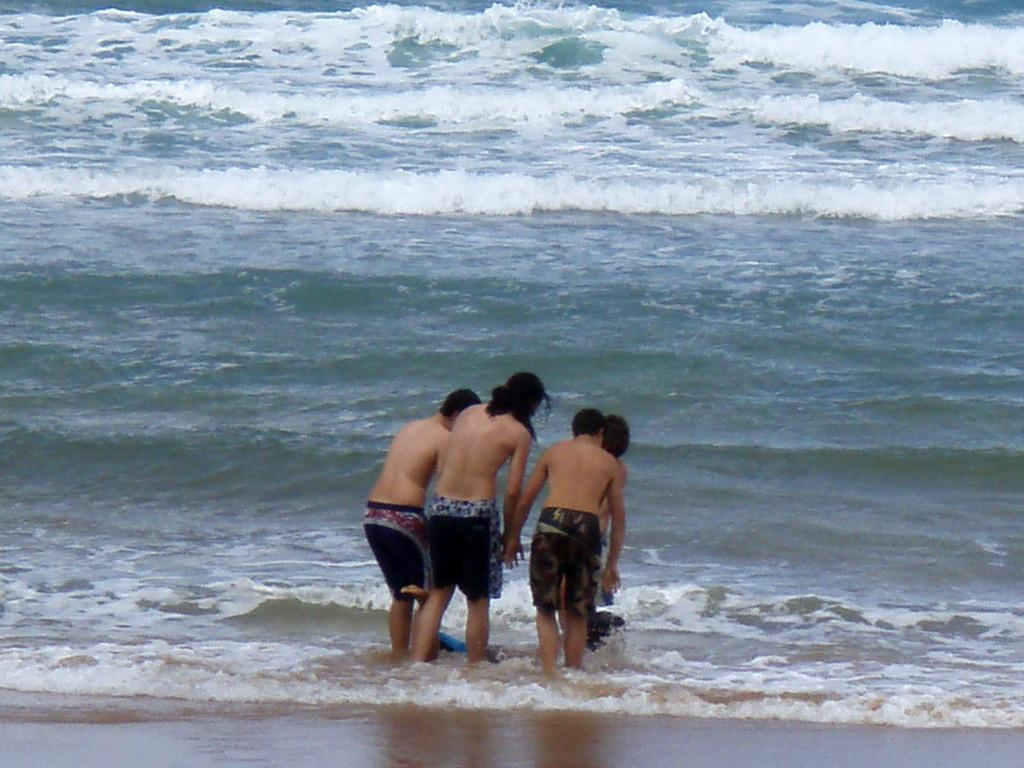What is the main focus of the image? The main focus of the image is the people in the center. Can you describe the surrounding environment in the image? There is water around the area of the image. What hobbies do the people in the image engage in? The provided facts do not mention any hobbies of the people in the image, so we cannot determine their hobbies from the image. 